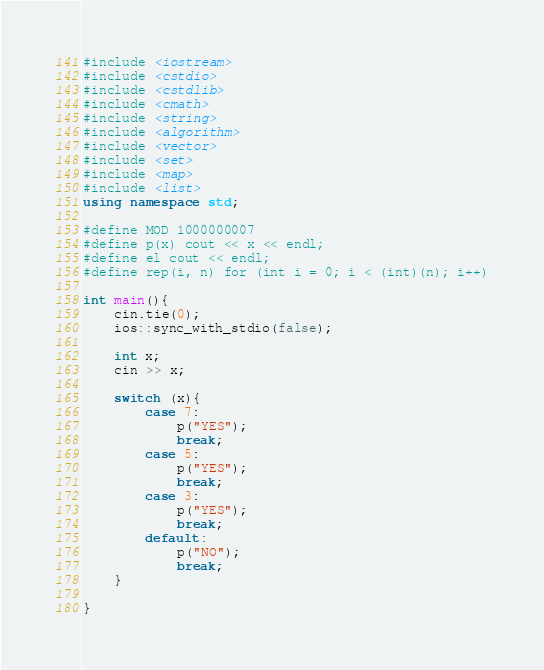Convert code to text. <code><loc_0><loc_0><loc_500><loc_500><_C++_>#include <iostream>
#include <cstdio>
#include <cstdlib>
#include <cmath>
#include <string>
#include <algorithm>
#include <vector>
#include <set>
#include <map>
#include <list>
using namespace std;

#define MOD 1000000007
#define p(x) cout << x << endl;
#define el cout << endl;
#define rep(i, n) for (int i = 0; i < (int)(n); i++)

int main(){
    cin.tie(0);
    ios::sync_with_stdio(false);

    int x;
    cin >> x;

    switch (x){
        case 7:
            p("YES");
            break;
        case 5:
            p("YES");
            break;
        case 3:
            p("YES");
            break;
        default:
            p("NO");
            break;
    }

}
</code> 